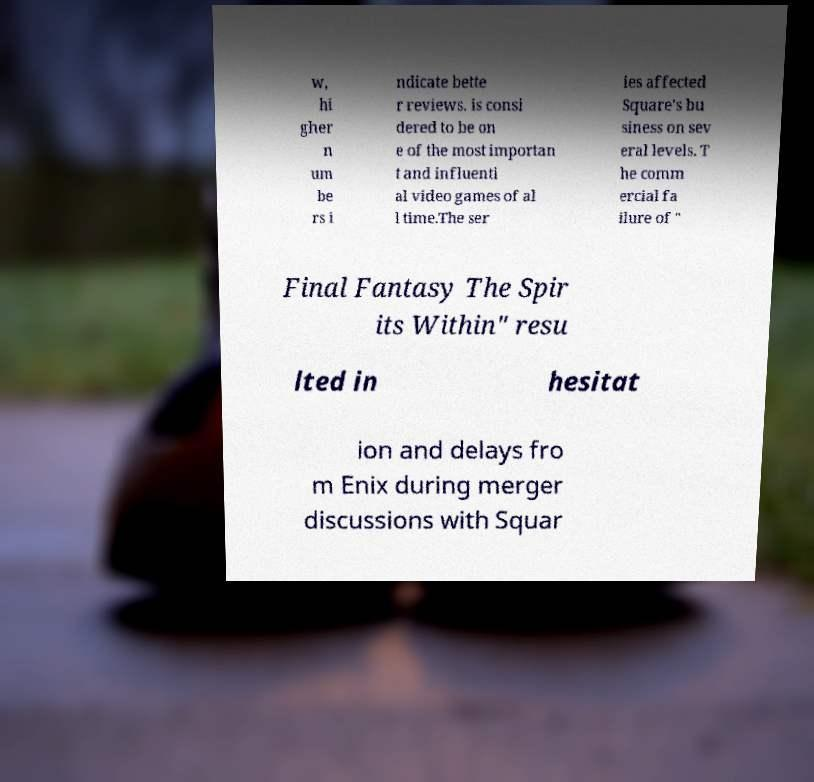I need the written content from this picture converted into text. Can you do that? w, hi gher n um be rs i ndicate bette r reviews. is consi dered to be on e of the most importan t and influenti al video games of al l time.The ser ies affected Square's bu siness on sev eral levels. T he comm ercial fa ilure of " Final Fantasy The Spir its Within" resu lted in hesitat ion and delays fro m Enix during merger discussions with Squar 